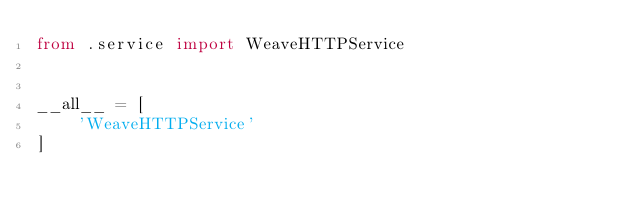<code> <loc_0><loc_0><loc_500><loc_500><_Python_>from .service import WeaveHTTPService


__all__ = [
    'WeaveHTTPService'
]
</code> 